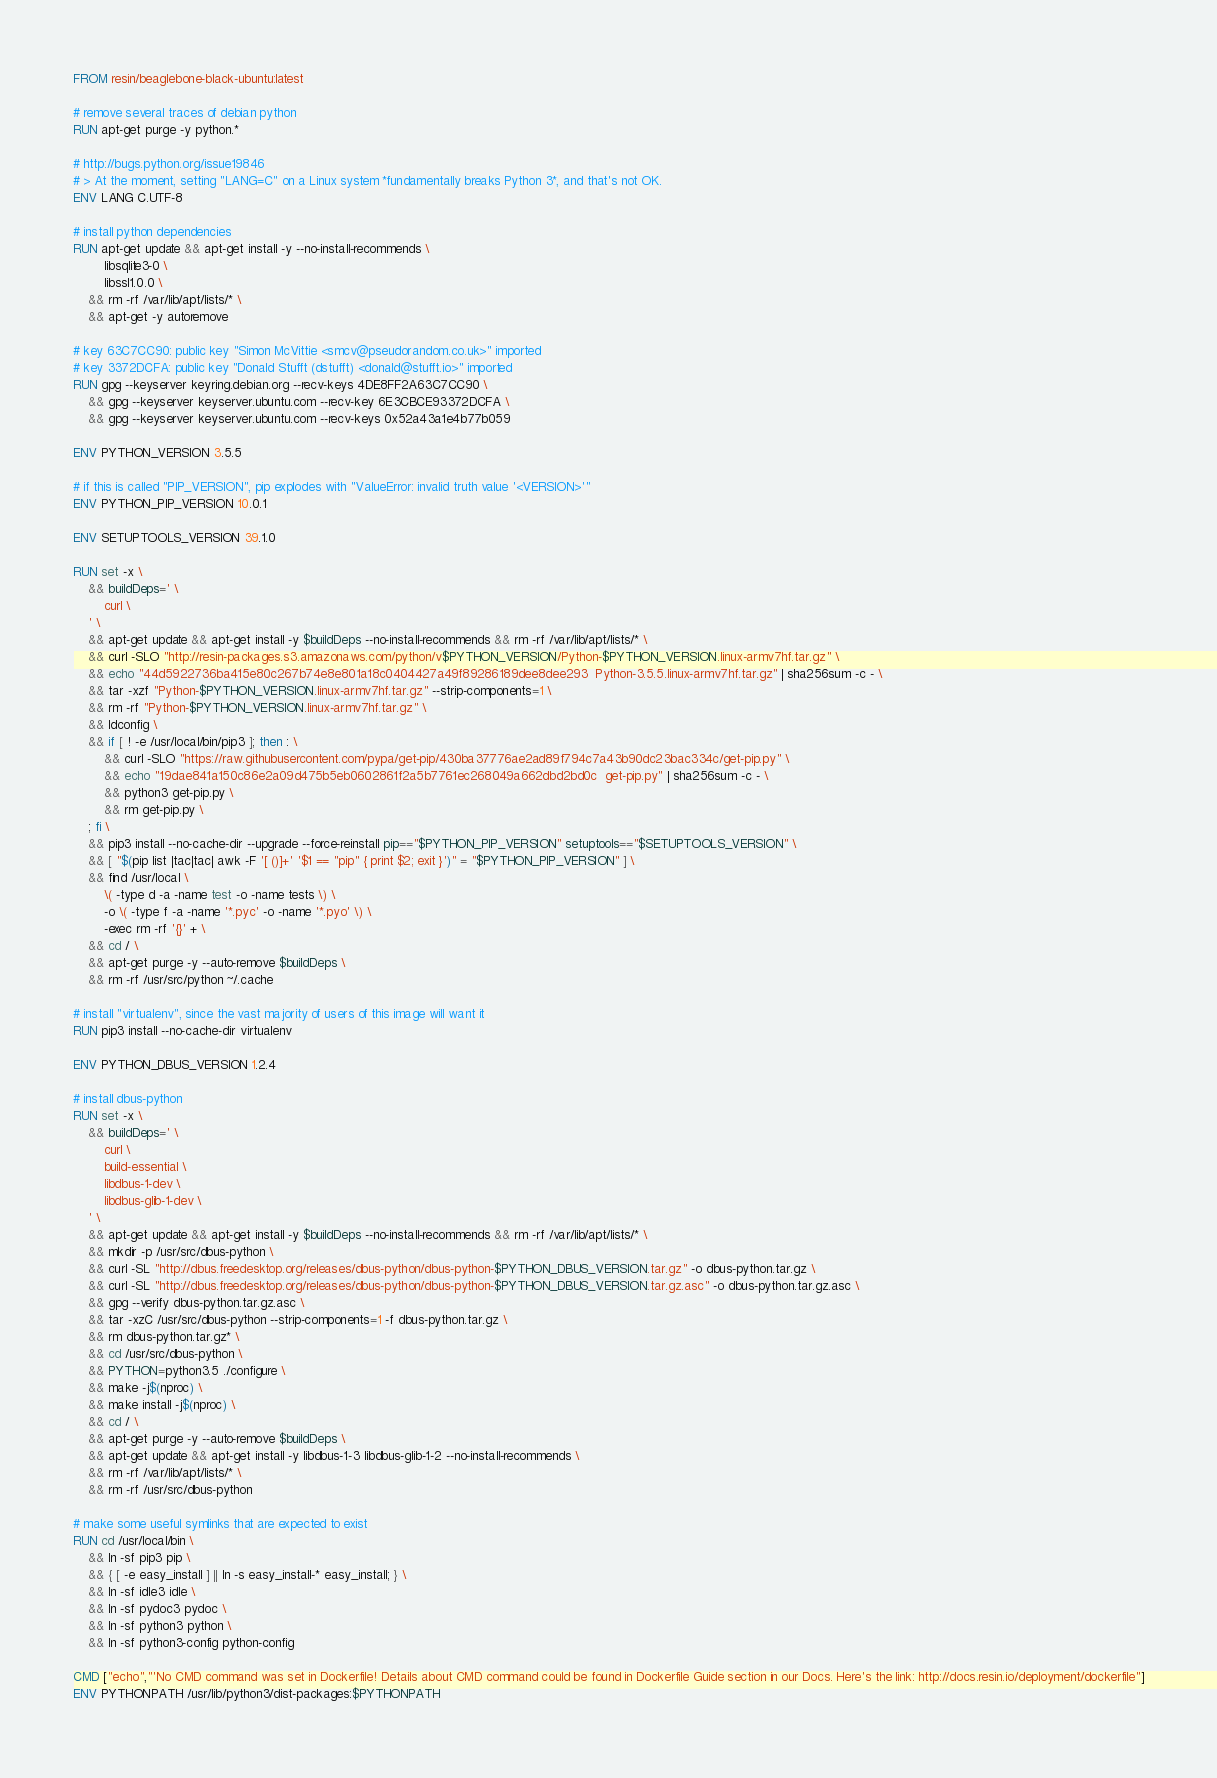Convert code to text. <code><loc_0><loc_0><loc_500><loc_500><_Dockerfile_>FROM resin/beaglebone-black-ubuntu:latest

# remove several traces of debian python
RUN apt-get purge -y python.*

# http://bugs.python.org/issue19846
# > At the moment, setting "LANG=C" on a Linux system *fundamentally breaks Python 3*, and that's not OK.
ENV LANG C.UTF-8

# install python dependencies
RUN apt-get update && apt-get install -y --no-install-recommends \
		libsqlite3-0 \
		libssl1.0.0 \
	&& rm -rf /var/lib/apt/lists/* \
	&& apt-get -y autoremove

# key 63C7CC90: public key "Simon McVittie <smcv@pseudorandom.co.uk>" imported
# key 3372DCFA: public key "Donald Stufft (dstufft) <donald@stufft.io>" imported
RUN gpg --keyserver keyring.debian.org --recv-keys 4DE8FF2A63C7CC90 \
	&& gpg --keyserver keyserver.ubuntu.com --recv-key 6E3CBCE93372DCFA \
	&& gpg --keyserver keyserver.ubuntu.com --recv-keys 0x52a43a1e4b77b059

ENV PYTHON_VERSION 3.5.5

# if this is called "PIP_VERSION", pip explodes with "ValueError: invalid truth value '<VERSION>'"
ENV PYTHON_PIP_VERSION 10.0.1

ENV SETUPTOOLS_VERSION 39.1.0

RUN set -x \
	&& buildDeps=' \
		curl \
	' \
	&& apt-get update && apt-get install -y $buildDeps --no-install-recommends && rm -rf /var/lib/apt/lists/* \
	&& curl -SLO "http://resin-packages.s3.amazonaws.com/python/v$PYTHON_VERSION/Python-$PYTHON_VERSION.linux-armv7hf.tar.gz" \
	&& echo "44d5922736ba415e80c267b74e8e801a18c0404427a49f89286189dee8dee293  Python-3.5.5.linux-armv7hf.tar.gz" | sha256sum -c - \
	&& tar -xzf "Python-$PYTHON_VERSION.linux-armv7hf.tar.gz" --strip-components=1 \
	&& rm -rf "Python-$PYTHON_VERSION.linux-armv7hf.tar.gz" \
	&& ldconfig \
	&& if [ ! -e /usr/local/bin/pip3 ]; then : \
		&& curl -SLO "https://raw.githubusercontent.com/pypa/get-pip/430ba37776ae2ad89f794c7a43b90dc23bac334c/get-pip.py" \
		&& echo "19dae841a150c86e2a09d475b5eb0602861f2a5b7761ec268049a662dbd2bd0c  get-pip.py" | sha256sum -c - \
		&& python3 get-pip.py \
		&& rm get-pip.py \
	; fi \
	&& pip3 install --no-cache-dir --upgrade --force-reinstall pip=="$PYTHON_PIP_VERSION" setuptools=="$SETUPTOOLS_VERSION" \
	&& [ "$(pip list |tac|tac| awk -F '[ ()]+' '$1 == "pip" { print $2; exit }')" = "$PYTHON_PIP_VERSION" ] \
	&& find /usr/local \
		\( -type d -a -name test -o -name tests \) \
		-o \( -type f -a -name '*.pyc' -o -name '*.pyo' \) \
		-exec rm -rf '{}' + \
	&& cd / \
	&& apt-get purge -y --auto-remove $buildDeps \
	&& rm -rf /usr/src/python ~/.cache

# install "virtualenv", since the vast majority of users of this image will want it
RUN pip3 install --no-cache-dir virtualenv

ENV PYTHON_DBUS_VERSION 1.2.4

# install dbus-python
RUN set -x \
	&& buildDeps=' \
		curl \
		build-essential \
		libdbus-1-dev \
		libdbus-glib-1-dev \
	' \
	&& apt-get update && apt-get install -y $buildDeps --no-install-recommends && rm -rf /var/lib/apt/lists/* \
	&& mkdir -p /usr/src/dbus-python \
	&& curl -SL "http://dbus.freedesktop.org/releases/dbus-python/dbus-python-$PYTHON_DBUS_VERSION.tar.gz" -o dbus-python.tar.gz \
	&& curl -SL "http://dbus.freedesktop.org/releases/dbus-python/dbus-python-$PYTHON_DBUS_VERSION.tar.gz.asc" -o dbus-python.tar.gz.asc \
	&& gpg --verify dbus-python.tar.gz.asc \
	&& tar -xzC /usr/src/dbus-python --strip-components=1 -f dbus-python.tar.gz \
	&& rm dbus-python.tar.gz* \
	&& cd /usr/src/dbus-python \
	&& PYTHON=python3.5 ./configure \
	&& make -j$(nproc) \
	&& make install -j$(nproc) \
	&& cd / \
	&& apt-get purge -y --auto-remove $buildDeps \
	&& apt-get update && apt-get install -y libdbus-1-3 libdbus-glib-1-2 --no-install-recommends \
	&& rm -rf /var/lib/apt/lists/* \
	&& rm -rf /usr/src/dbus-python

# make some useful symlinks that are expected to exist
RUN cd /usr/local/bin \
	&& ln -sf pip3 pip \
	&& { [ -e easy_install ] || ln -s easy_install-* easy_install; } \
	&& ln -sf idle3 idle \
	&& ln -sf pydoc3 pydoc \
	&& ln -sf python3 python \
	&& ln -sf python3-config python-config

CMD ["echo","'No CMD command was set in Dockerfile! Details about CMD command could be found in Dockerfile Guide section in our Docs. Here's the link: http://docs.resin.io/deployment/dockerfile"]
ENV PYTHONPATH /usr/lib/python3/dist-packages:$PYTHONPATH
</code> 